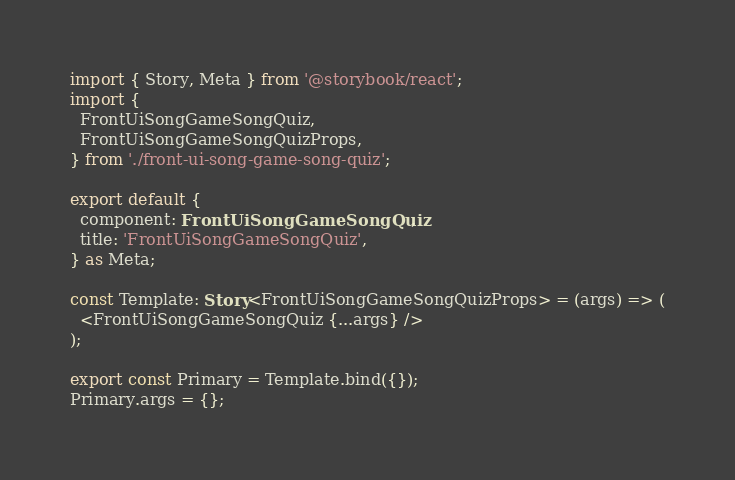Convert code to text. <code><loc_0><loc_0><loc_500><loc_500><_TypeScript_>import { Story, Meta } from '@storybook/react';
import {
  FrontUiSongGameSongQuiz,
  FrontUiSongGameSongQuizProps,
} from './front-ui-song-game-song-quiz';

export default {
  component: FrontUiSongGameSongQuiz,
  title: 'FrontUiSongGameSongQuiz',
} as Meta;

const Template: Story<FrontUiSongGameSongQuizProps> = (args) => (
  <FrontUiSongGameSongQuiz {...args} />
);

export const Primary = Template.bind({});
Primary.args = {};
</code> 